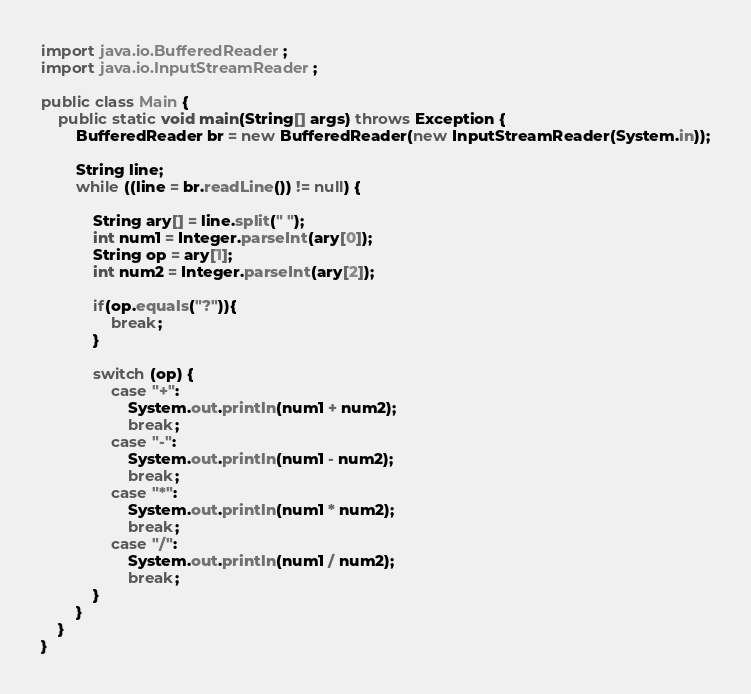<code> <loc_0><loc_0><loc_500><loc_500><_Java_>import java.io.BufferedReader;
import java.io.InputStreamReader;

public class Main {
    public static void main(String[] args) throws Exception {
        BufferedReader br = new BufferedReader(new InputStreamReader(System.in));
        
        String line;
        while ((line = br.readLine()) != null) {
        
            String ary[] = line.split(" ");
            int num1 = Integer.parseInt(ary[0]);
            String op = ary[1];
            int num2 = Integer.parseInt(ary[2]);
            
            if(op.equals("?")){
                break;
            }
            
            switch (op) {
                case "+":
                    System.out.println(num1 + num2);
                    break;
                case "-":
                    System.out.println(num1 - num2);
                    break;
                case "*":
                    System.out.println(num1 * num2);
                    break;
                case "/":
                    System.out.println(num1 / num2);
                    break;
            }
        }
    }
}</code> 